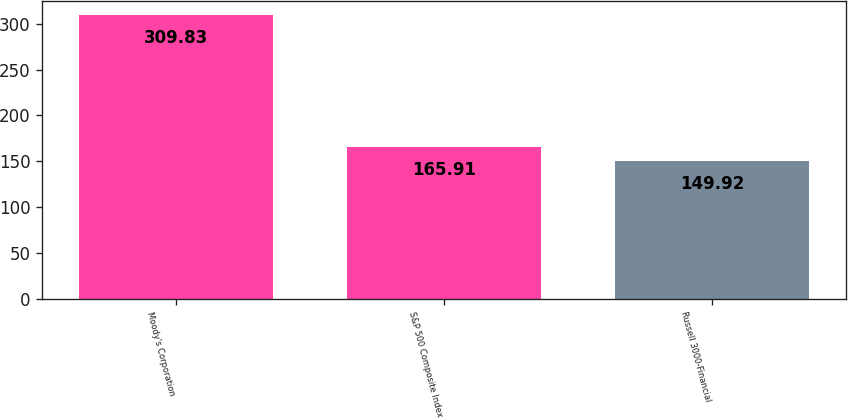Convert chart to OTSL. <chart><loc_0><loc_0><loc_500><loc_500><bar_chart><fcel>Moody's Corporation<fcel>S&P 500 Composite Index<fcel>Russell 3000-Financial<nl><fcel>309.83<fcel>165.91<fcel>149.92<nl></chart> 